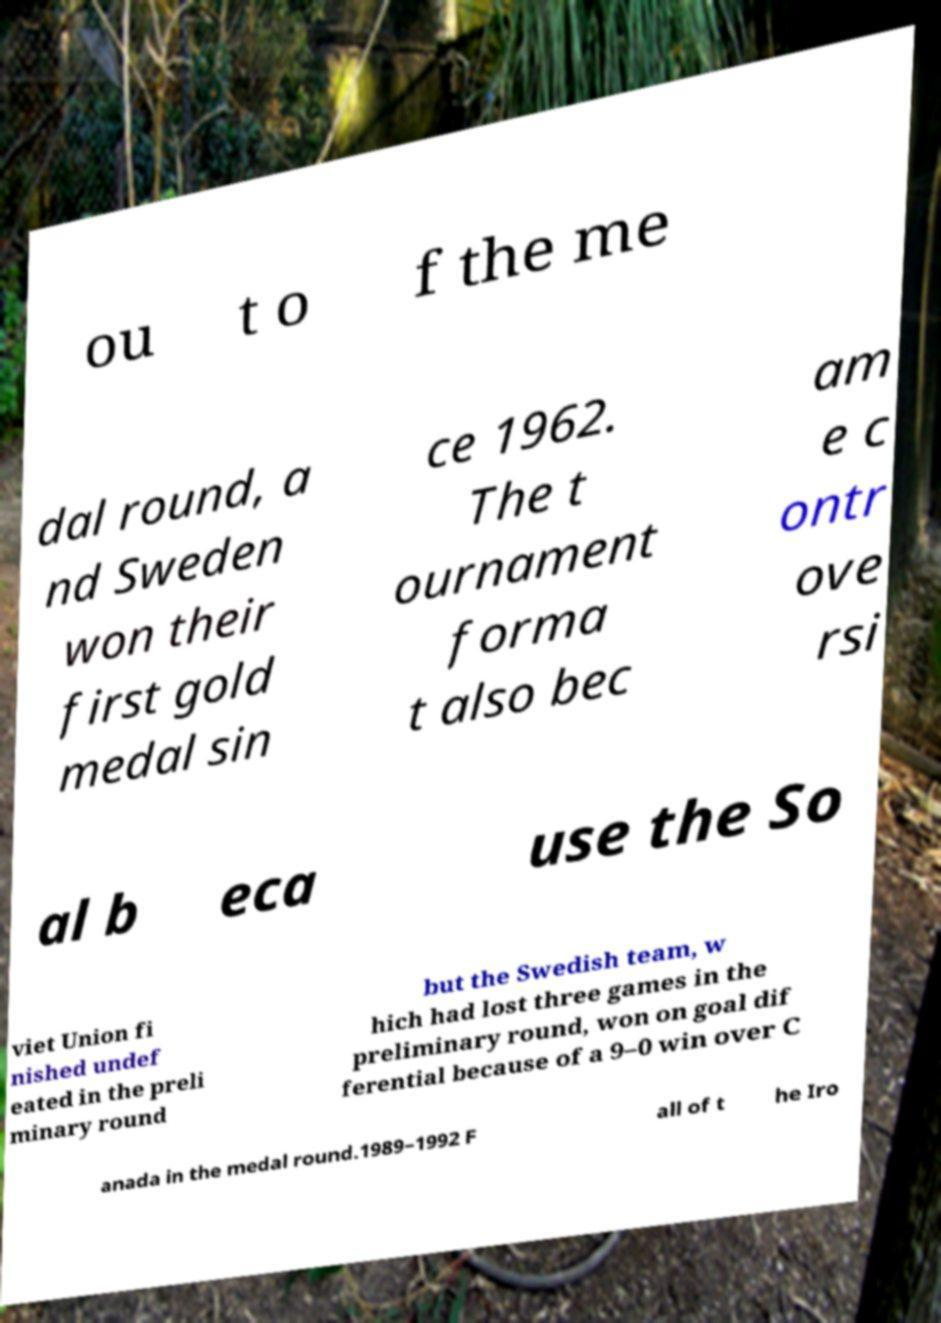For documentation purposes, I need the text within this image transcribed. Could you provide that? ou t o f the me dal round, a nd Sweden won their first gold medal sin ce 1962. The t ournament forma t also bec am e c ontr ove rsi al b eca use the So viet Union fi nished undef eated in the preli minary round but the Swedish team, w hich had lost three games in the preliminary round, won on goal dif ferential because of a 9–0 win over C anada in the medal round.1989–1992 F all of t he Iro 